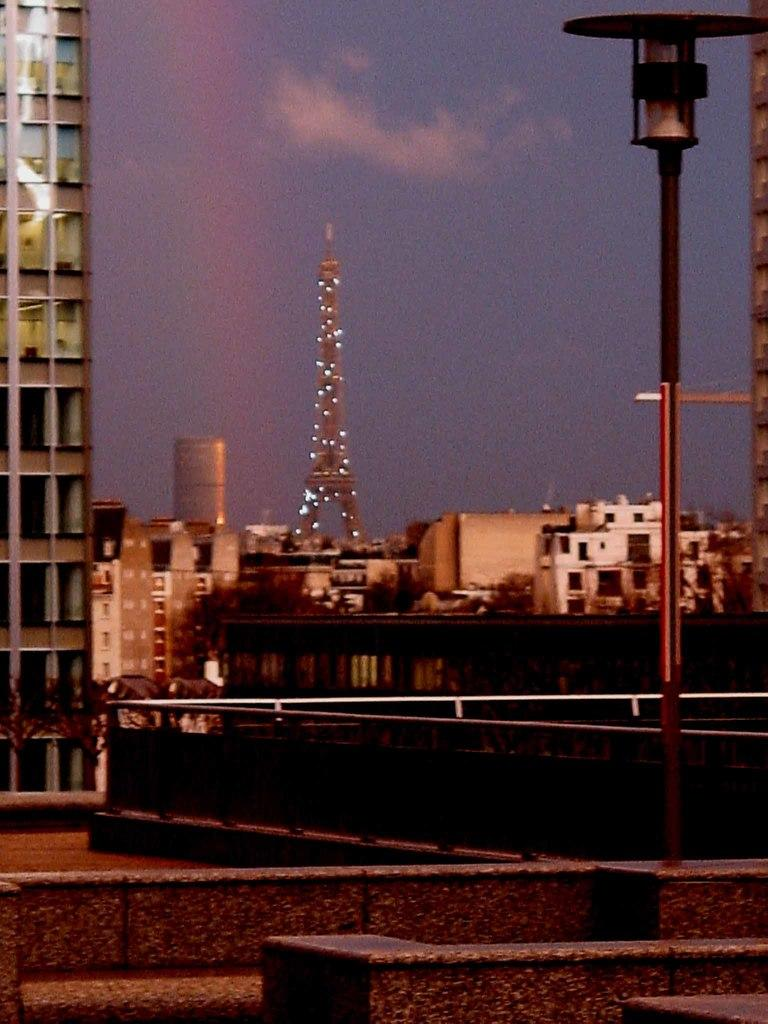What type of structures can be seen in the image? There are buildings and a tower in the image. Are there any other objects or features visible in the image? Yes, there are poles in the image. What can be seen in the background of the image? The sky is visible in the background of the image. What type of representative is present in the image? There is no representative present in the image; it features buildings, a tower, and poles. Can you describe the mist in the image? There is no mist present in the image; it features clear skies in the background. 